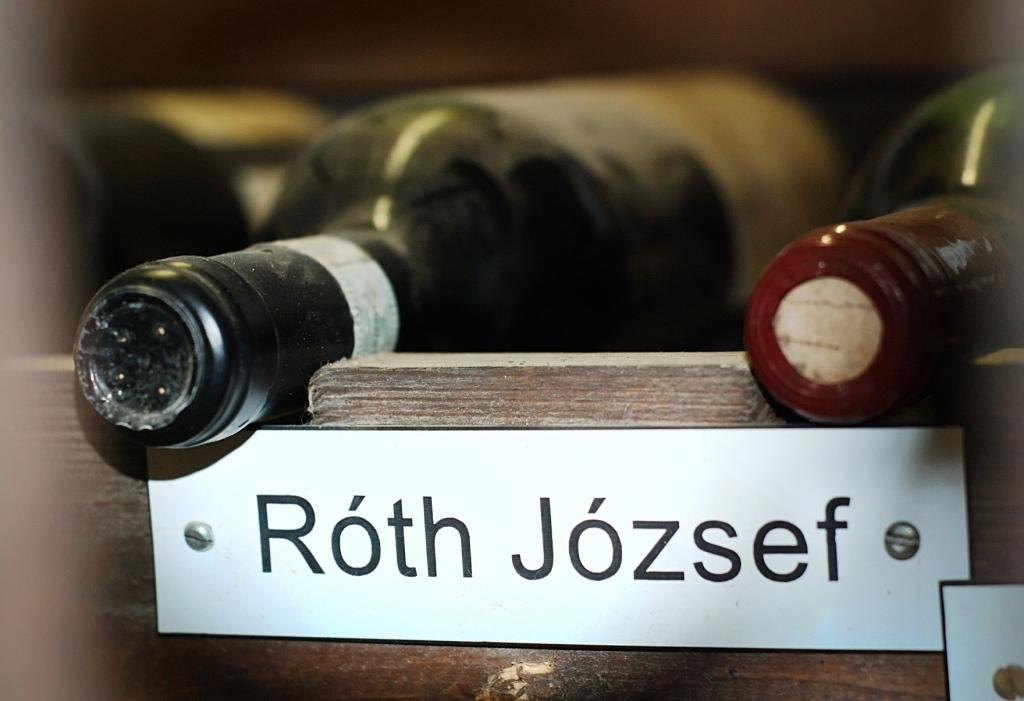<image>
Describe the image concisely. Two bottles of wine lay in a rack over a label that reads "Roth Jozsef". 